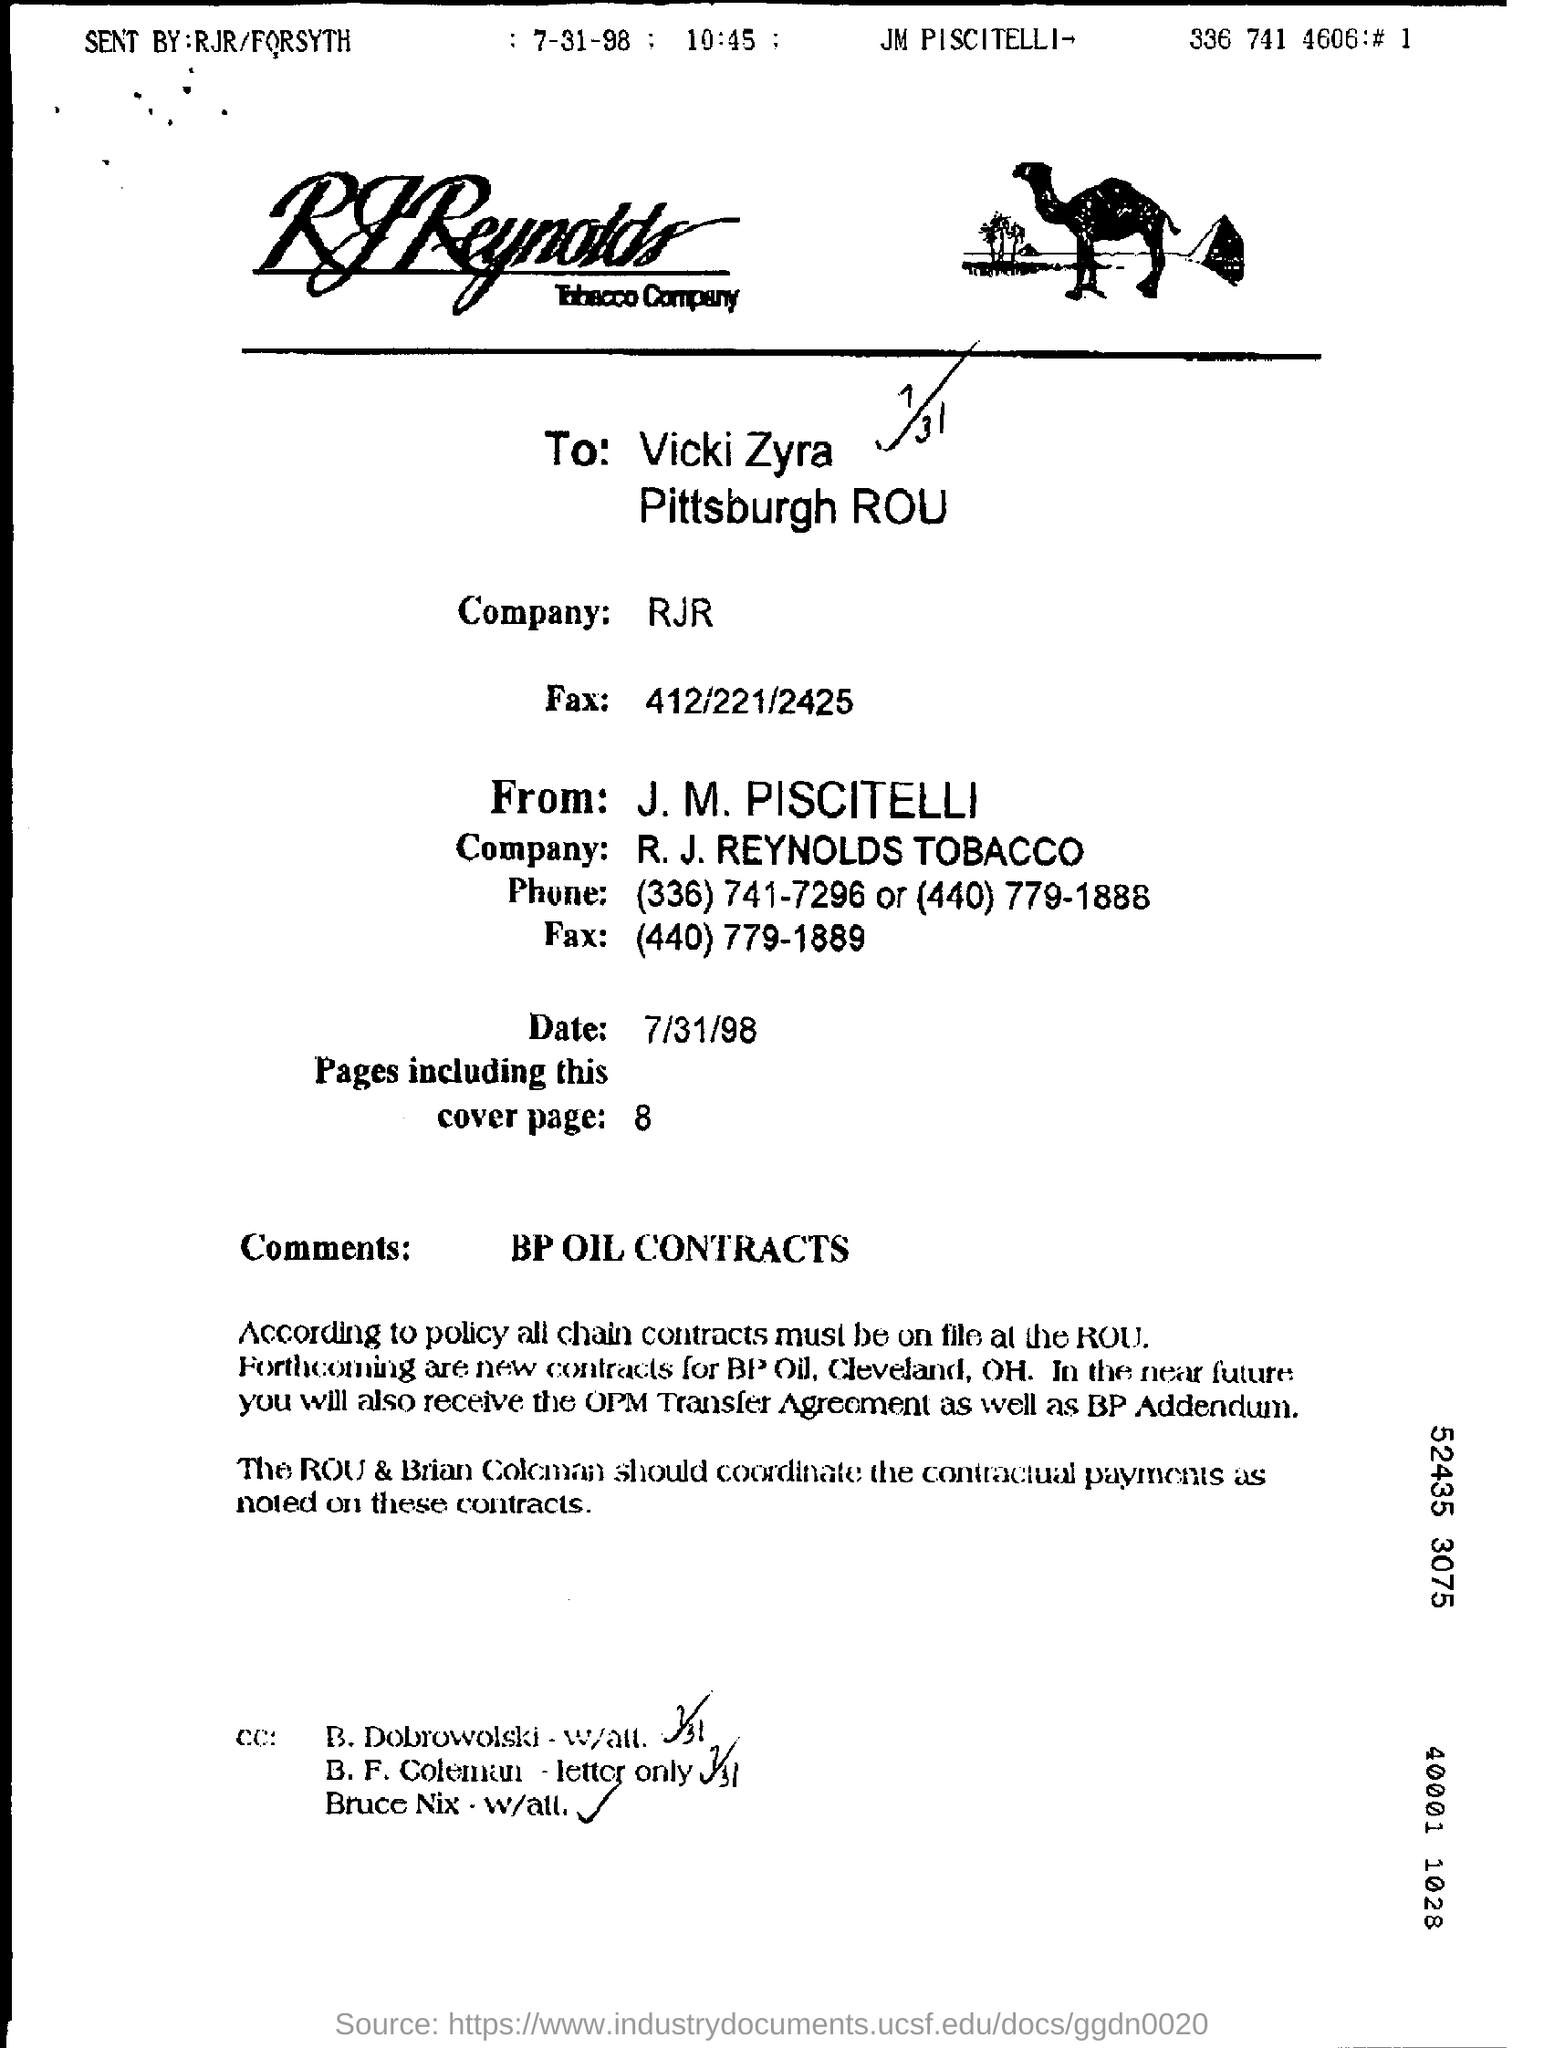List a handful of essential elements in this visual. The total number of pages in the fax, including the cover page, is 8. The document is addressed to Vicki Zyra in Pittsburgh. The date is July 31, 1998. 